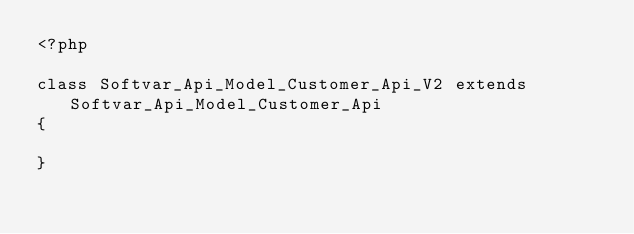Convert code to text. <code><loc_0><loc_0><loc_500><loc_500><_PHP_><?php

class Softvar_Api_Model_Customer_Api_V2 extends Softvar_Api_Model_Customer_Api
{

}</code> 